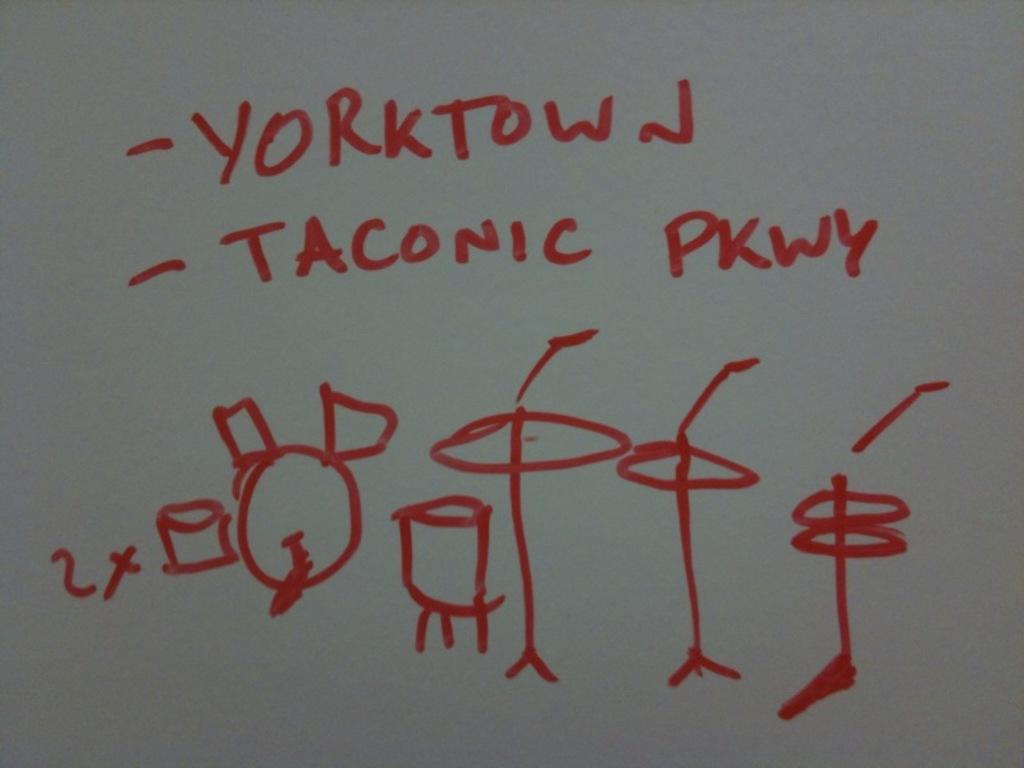<image>
Share a concise interpretation of the image provided. the word Yorktown that is on a board 